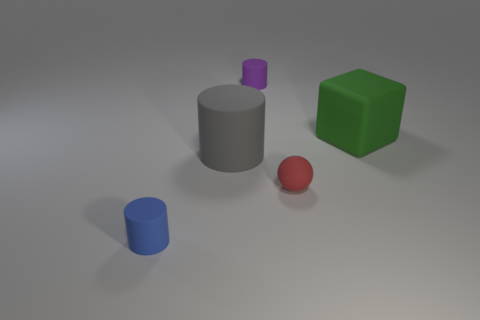What is the shape of the purple matte thing that is the same size as the blue cylinder?
Offer a terse response. Cylinder. The tiny object behind the big matte thing that is left of the cylinder that is behind the gray cylinder is what shape?
Your answer should be very brief. Cylinder. How many small things are there?
Your answer should be very brief. 3. Are there any tiny red things behind the big green matte object?
Keep it short and to the point. No. Are there fewer blue rubber cylinders right of the red matte thing than big gray cylinders?
Your answer should be very brief. Yes. The big thing that is in front of the matte cube is what color?
Offer a terse response. Gray. What material is the large object that is on the left side of the small cylinder that is behind the tiny blue object?
Provide a short and direct response. Rubber. Is there a blue rubber thing that has the same size as the purple cylinder?
Give a very brief answer. Yes. What number of things are either matte objects behind the large green object or matte things behind the small ball?
Provide a short and direct response. 3. Is the size of the rubber cylinder that is behind the large green rubber object the same as the matte object on the right side of the red matte object?
Make the answer very short. No. 